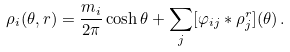<formula> <loc_0><loc_0><loc_500><loc_500>\rho _ { i } ( \theta , r ) = \frac { m _ { i } } { 2 \pi } \cosh \theta + \sum _ { j } [ \varphi _ { i j } \ast \rho _ { j } ^ { r } ] ( \theta ) \, .</formula> 